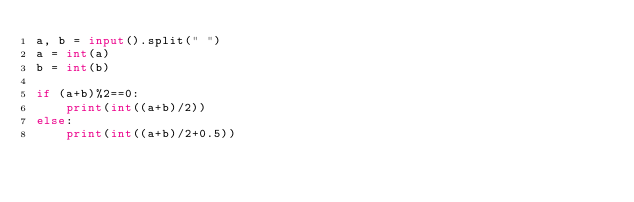<code> <loc_0><loc_0><loc_500><loc_500><_Python_>a, b = input().split(" ")
a = int(a)
b = int(b)

if (a+b)%2==0:
    print(int((a+b)/2))
else:
    print(int((a+b)/2+0.5))
</code> 